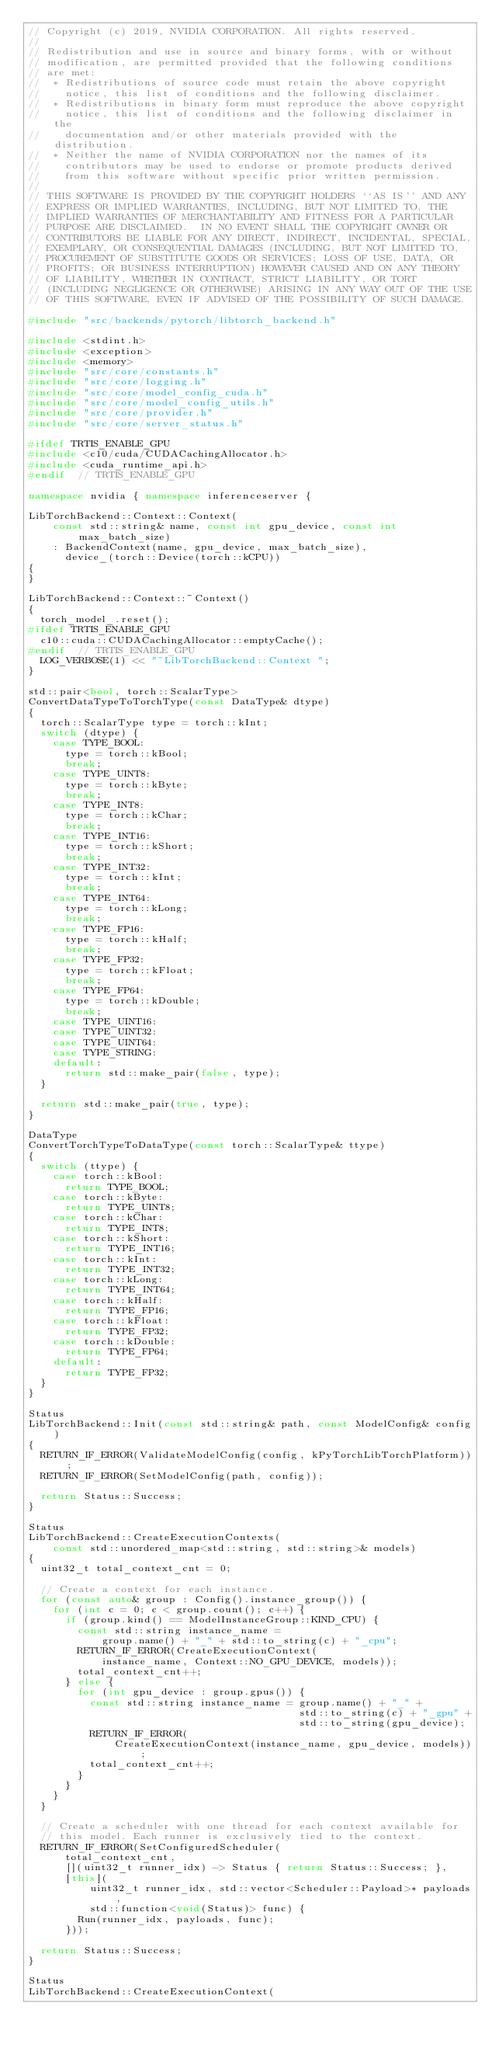Convert code to text. <code><loc_0><loc_0><loc_500><loc_500><_C++_>// Copyright (c) 2019, NVIDIA CORPORATION. All rights reserved.
//
// Redistribution and use in source and binary forms, with or without
// modification, are permitted provided that the following conditions
// are met:
//  * Redistributions of source code must retain the above copyright
//    notice, this list of conditions and the following disclaimer.
//  * Redistributions in binary form must reproduce the above copyright
//    notice, this list of conditions and the following disclaimer in the
//    documentation and/or other materials provided with the distribution.
//  * Neither the name of NVIDIA CORPORATION nor the names of its
//    contributors may be used to endorse or promote products derived
//    from this software without specific prior written permission.
//
// THIS SOFTWARE IS PROVIDED BY THE COPYRIGHT HOLDERS ``AS IS'' AND ANY
// EXPRESS OR IMPLIED WARRANTIES, INCLUDING, BUT NOT LIMITED TO, THE
// IMPLIED WARRANTIES OF MERCHANTABILITY AND FITNESS FOR A PARTICULAR
// PURPOSE ARE DISCLAIMED.  IN NO EVENT SHALL THE COPYRIGHT OWNER OR
// CONTRIBUTORS BE LIABLE FOR ANY DIRECT, INDIRECT, INCIDENTAL, SPECIAL,
// EXEMPLARY, OR CONSEQUENTIAL DAMAGES (INCLUDING, BUT NOT LIMITED TO,
// PROCUREMENT OF SUBSTITUTE GOODS OR SERVICES; LOSS OF USE, DATA, OR
// PROFITS; OR BUSINESS INTERRUPTION) HOWEVER CAUSED AND ON ANY THEORY
// OF LIABILITY, WHETHER IN CONTRACT, STRICT LIABILITY, OR TORT
// (INCLUDING NEGLIGENCE OR OTHERWISE) ARISING IN ANY WAY OUT OF THE USE
// OF THIS SOFTWARE, EVEN IF ADVISED OF THE POSSIBILITY OF SUCH DAMAGE.

#include "src/backends/pytorch/libtorch_backend.h"

#include <stdint.h>
#include <exception>
#include <memory>
#include "src/core/constants.h"
#include "src/core/logging.h"
#include "src/core/model_config_cuda.h"
#include "src/core/model_config_utils.h"
#include "src/core/provider.h"
#include "src/core/server_status.h"

#ifdef TRTIS_ENABLE_GPU
#include <c10/cuda/CUDACachingAllocator.h>
#include <cuda_runtime_api.h>
#endif  // TRTIS_ENABLE_GPU

namespace nvidia { namespace inferenceserver {

LibTorchBackend::Context::Context(
    const std::string& name, const int gpu_device, const int max_batch_size)
    : BackendContext(name, gpu_device, max_batch_size),
      device_(torch::Device(torch::kCPU))
{
}

LibTorchBackend::Context::~Context()
{
  torch_model_.reset();
#ifdef TRTIS_ENABLE_GPU
  c10::cuda::CUDACachingAllocator::emptyCache();
#endif  // TRTIS_ENABLE_GPU
  LOG_VERBOSE(1) << "~LibTorchBackend::Context ";
}

std::pair<bool, torch::ScalarType>
ConvertDataTypeToTorchType(const DataType& dtype)
{
  torch::ScalarType type = torch::kInt;
  switch (dtype) {
    case TYPE_BOOL:
      type = torch::kBool;
      break;
    case TYPE_UINT8:
      type = torch::kByte;
      break;
    case TYPE_INT8:
      type = torch::kChar;
      break;
    case TYPE_INT16:
      type = torch::kShort;
      break;
    case TYPE_INT32:
      type = torch::kInt;
      break;
    case TYPE_INT64:
      type = torch::kLong;
      break;
    case TYPE_FP16:
      type = torch::kHalf;
      break;
    case TYPE_FP32:
      type = torch::kFloat;
      break;
    case TYPE_FP64:
      type = torch::kDouble;
      break;
    case TYPE_UINT16:
    case TYPE_UINT32:
    case TYPE_UINT64:
    case TYPE_STRING:
    default:
      return std::make_pair(false, type);
  }

  return std::make_pair(true, type);
}

DataType
ConvertTorchTypeToDataType(const torch::ScalarType& ttype)
{
  switch (ttype) {
    case torch::kBool:
      return TYPE_BOOL;
    case torch::kByte:
      return TYPE_UINT8;
    case torch::kChar:
      return TYPE_INT8;
    case torch::kShort:
      return TYPE_INT16;
    case torch::kInt:
      return TYPE_INT32;
    case torch::kLong:
      return TYPE_INT64;
    case torch::kHalf:
      return TYPE_FP16;
    case torch::kFloat:
      return TYPE_FP32;
    case torch::kDouble:
      return TYPE_FP64;
    default:
      return TYPE_FP32;
  }
}

Status
LibTorchBackend::Init(const std::string& path, const ModelConfig& config)
{
  RETURN_IF_ERROR(ValidateModelConfig(config, kPyTorchLibTorchPlatform));
  RETURN_IF_ERROR(SetModelConfig(path, config));

  return Status::Success;
}

Status
LibTorchBackend::CreateExecutionContexts(
    const std::unordered_map<std::string, std::string>& models)
{
  uint32_t total_context_cnt = 0;

  // Create a context for each instance.
  for (const auto& group : Config().instance_group()) {
    for (int c = 0; c < group.count(); c++) {
      if (group.kind() == ModelInstanceGroup::KIND_CPU) {
        const std::string instance_name =
            group.name() + "_" + std::to_string(c) + "_cpu";
        RETURN_IF_ERROR(CreateExecutionContext(
            instance_name, Context::NO_GPU_DEVICE, models));
        total_context_cnt++;
      } else {
        for (int gpu_device : group.gpus()) {
          const std::string instance_name = group.name() + "_" +
                                            std::to_string(c) + "_gpu" +
                                            std::to_string(gpu_device);
          RETURN_IF_ERROR(
              CreateExecutionContext(instance_name, gpu_device, models));
          total_context_cnt++;
        }
      }
    }
  }

  // Create a scheduler with one thread for each context available for
  // this model. Each runner is exclusively tied to the context.
  RETURN_IF_ERROR(SetConfiguredScheduler(
      total_context_cnt,
      [](uint32_t runner_idx) -> Status { return Status::Success; },
      [this](
          uint32_t runner_idx, std::vector<Scheduler::Payload>* payloads,
          std::function<void(Status)> func) {
        Run(runner_idx, payloads, func);
      }));

  return Status::Success;
}

Status
LibTorchBackend::CreateExecutionContext(</code> 